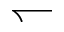<formula> <loc_0><loc_0><loc_500><loc_500>\leftharpoondown</formula> 